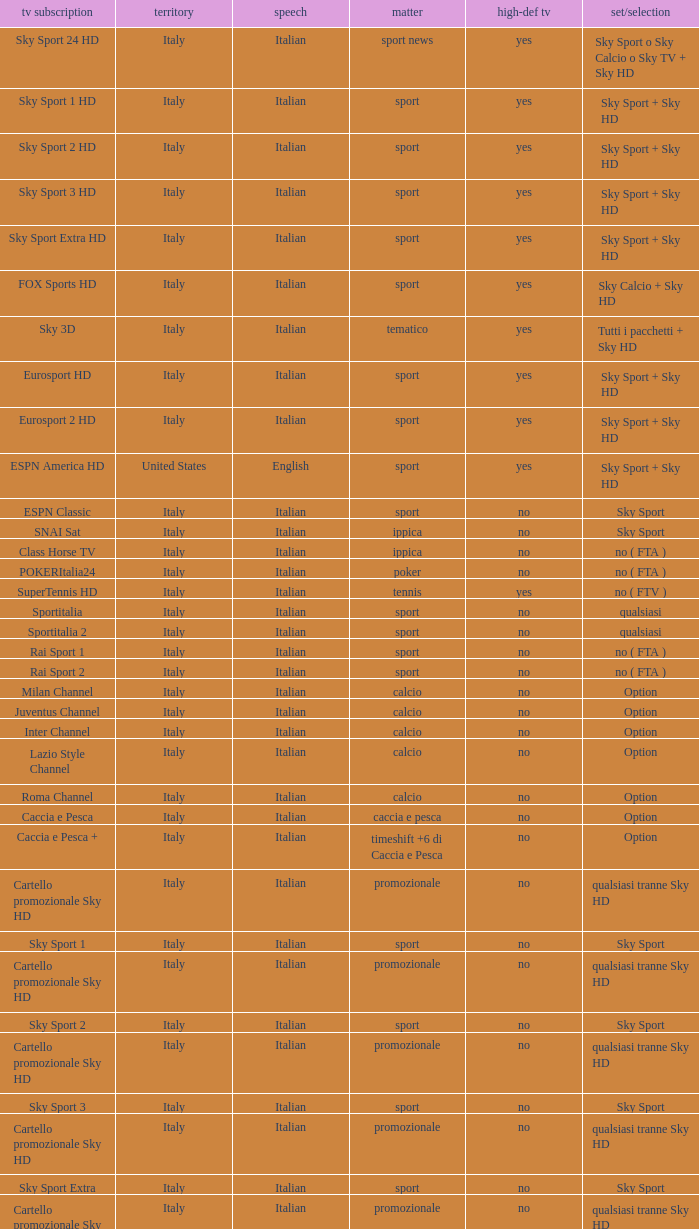What is Language, when Content is Sport, when HDTV is No, and when Television Service is ESPN America? Italian. 